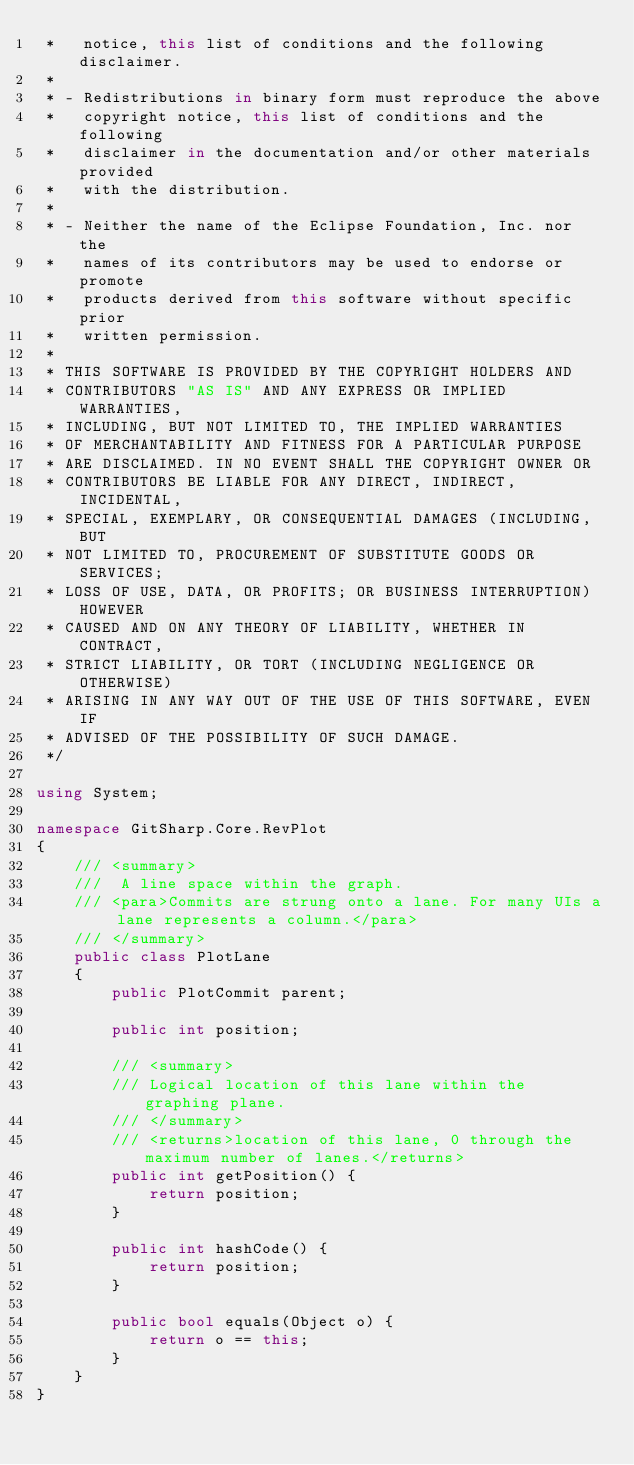<code> <loc_0><loc_0><loc_500><loc_500><_C#_> *   notice, this list of conditions and the following disclaimer.
 *
 * - Redistributions in binary form must reproduce the above
 *   copyright notice, this list of conditions and the following
 *   disclaimer in the documentation and/or other materials provided
 *   with the distribution.
 *
 * - Neither the name of the Eclipse Foundation, Inc. nor the
 *   names of its contributors may be used to endorse or promote
 *   products derived from this software without specific prior
 *   written permission.
 *
 * THIS SOFTWARE IS PROVIDED BY THE COPYRIGHT HOLDERS AND
 * CONTRIBUTORS "AS IS" AND ANY EXPRESS OR IMPLIED WARRANTIES,
 * INCLUDING, BUT NOT LIMITED TO, THE IMPLIED WARRANTIES
 * OF MERCHANTABILITY AND FITNESS FOR A PARTICULAR PURPOSE
 * ARE DISCLAIMED. IN NO EVENT SHALL THE COPYRIGHT OWNER OR
 * CONTRIBUTORS BE LIABLE FOR ANY DIRECT, INDIRECT, INCIDENTAL,
 * SPECIAL, EXEMPLARY, OR CONSEQUENTIAL DAMAGES (INCLUDING, BUT
 * NOT LIMITED TO, PROCUREMENT OF SUBSTITUTE GOODS OR SERVICES;
 * LOSS OF USE, DATA, OR PROFITS; OR BUSINESS INTERRUPTION) HOWEVER
 * CAUSED AND ON ANY THEORY OF LIABILITY, WHETHER IN CONTRACT,
 * STRICT LIABILITY, OR TORT (INCLUDING NEGLIGENCE OR OTHERWISE)
 * ARISING IN ANY WAY OUT OF THE USE OF THIS SOFTWARE, EVEN IF
 * ADVISED OF THE POSSIBILITY OF SUCH DAMAGE.
 */

using System;

namespace GitSharp.Core.RevPlot
{
    /// <summary>
    ///  A line space within the graph.
    /// <para>Commits are strung onto a lane. For many UIs a lane represents a column.</para>
    /// </summary>
    public class PlotLane
    {
        public PlotCommit parent;

        public int position;

        /// <summary>
        /// Logical location of this lane within the graphing plane.
        /// </summary>
        /// <returns>location of this lane, 0 through the maximum number of lanes.</returns>
        public int getPosition() {
            return position;
        }

        public int hashCode() {
            return position;
        }

        public bool equals(Object o) {
            return o == this;
        }
    }
}</code> 